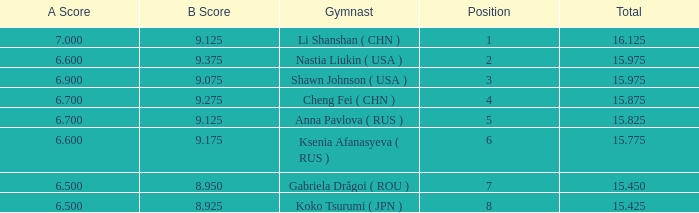What's the total that the position is less than 1? None. 